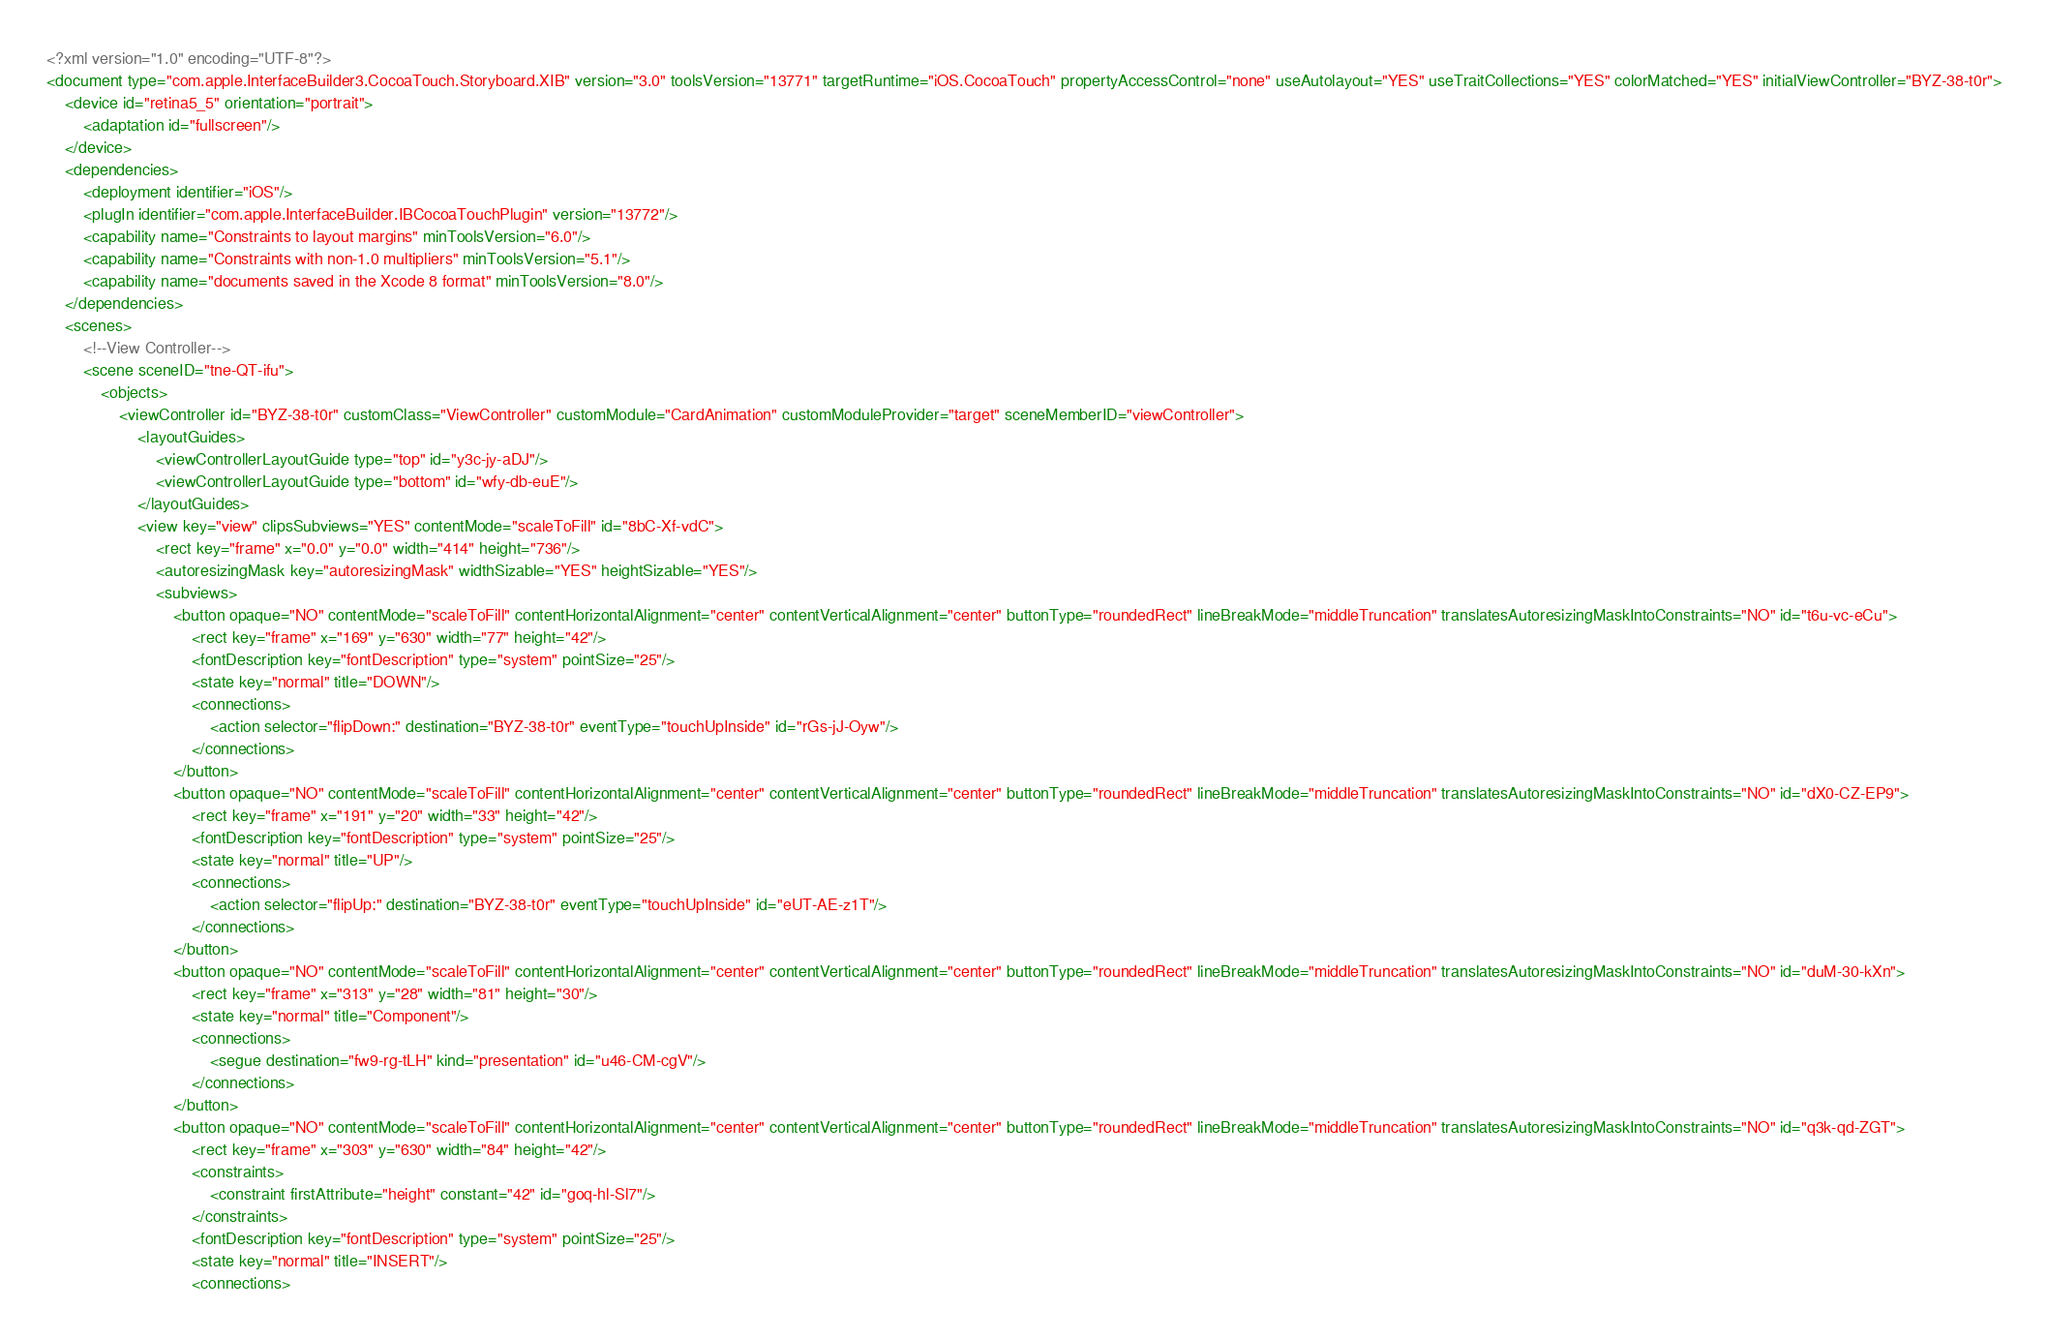<code> <loc_0><loc_0><loc_500><loc_500><_XML_><?xml version="1.0" encoding="UTF-8"?>
<document type="com.apple.InterfaceBuilder3.CocoaTouch.Storyboard.XIB" version="3.0" toolsVersion="13771" targetRuntime="iOS.CocoaTouch" propertyAccessControl="none" useAutolayout="YES" useTraitCollections="YES" colorMatched="YES" initialViewController="BYZ-38-t0r">
    <device id="retina5_5" orientation="portrait">
        <adaptation id="fullscreen"/>
    </device>
    <dependencies>
        <deployment identifier="iOS"/>
        <plugIn identifier="com.apple.InterfaceBuilder.IBCocoaTouchPlugin" version="13772"/>
        <capability name="Constraints to layout margins" minToolsVersion="6.0"/>
        <capability name="Constraints with non-1.0 multipliers" minToolsVersion="5.1"/>
        <capability name="documents saved in the Xcode 8 format" minToolsVersion="8.0"/>
    </dependencies>
    <scenes>
        <!--View Controller-->
        <scene sceneID="tne-QT-ifu">
            <objects>
                <viewController id="BYZ-38-t0r" customClass="ViewController" customModule="CardAnimation" customModuleProvider="target" sceneMemberID="viewController">
                    <layoutGuides>
                        <viewControllerLayoutGuide type="top" id="y3c-jy-aDJ"/>
                        <viewControllerLayoutGuide type="bottom" id="wfy-db-euE"/>
                    </layoutGuides>
                    <view key="view" clipsSubviews="YES" contentMode="scaleToFill" id="8bC-Xf-vdC">
                        <rect key="frame" x="0.0" y="0.0" width="414" height="736"/>
                        <autoresizingMask key="autoresizingMask" widthSizable="YES" heightSizable="YES"/>
                        <subviews>
                            <button opaque="NO" contentMode="scaleToFill" contentHorizontalAlignment="center" contentVerticalAlignment="center" buttonType="roundedRect" lineBreakMode="middleTruncation" translatesAutoresizingMaskIntoConstraints="NO" id="t6u-vc-eCu">
                                <rect key="frame" x="169" y="630" width="77" height="42"/>
                                <fontDescription key="fontDescription" type="system" pointSize="25"/>
                                <state key="normal" title="DOWN"/>
                                <connections>
                                    <action selector="flipDown:" destination="BYZ-38-t0r" eventType="touchUpInside" id="rGs-jJ-Oyw"/>
                                </connections>
                            </button>
                            <button opaque="NO" contentMode="scaleToFill" contentHorizontalAlignment="center" contentVerticalAlignment="center" buttonType="roundedRect" lineBreakMode="middleTruncation" translatesAutoresizingMaskIntoConstraints="NO" id="dX0-CZ-EP9">
                                <rect key="frame" x="191" y="20" width="33" height="42"/>
                                <fontDescription key="fontDescription" type="system" pointSize="25"/>
                                <state key="normal" title="UP"/>
                                <connections>
                                    <action selector="flipUp:" destination="BYZ-38-t0r" eventType="touchUpInside" id="eUT-AE-z1T"/>
                                </connections>
                            </button>
                            <button opaque="NO" contentMode="scaleToFill" contentHorizontalAlignment="center" contentVerticalAlignment="center" buttonType="roundedRect" lineBreakMode="middleTruncation" translatesAutoresizingMaskIntoConstraints="NO" id="duM-30-kXn">
                                <rect key="frame" x="313" y="28" width="81" height="30"/>
                                <state key="normal" title="Component"/>
                                <connections>
                                    <segue destination="fw9-rg-tLH" kind="presentation" id="u46-CM-cgV"/>
                                </connections>
                            </button>
                            <button opaque="NO" contentMode="scaleToFill" contentHorizontalAlignment="center" contentVerticalAlignment="center" buttonType="roundedRect" lineBreakMode="middleTruncation" translatesAutoresizingMaskIntoConstraints="NO" id="q3k-qd-ZGT">
                                <rect key="frame" x="303" y="630" width="84" height="42"/>
                                <constraints>
                                    <constraint firstAttribute="height" constant="42" id="goq-hl-Sl7"/>
                                </constraints>
                                <fontDescription key="fontDescription" type="system" pointSize="25"/>
                                <state key="normal" title="INSERT"/>
                                <connections></code> 